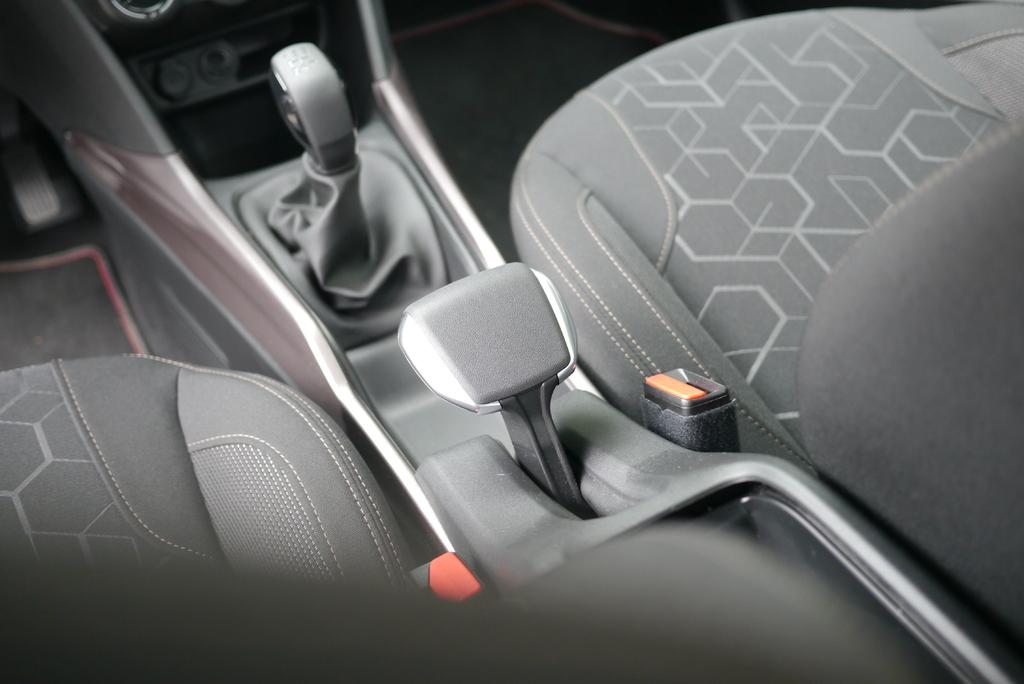What type of location is depicted in the image? The image is an inner view of a vehicle. How many seats are visible in the vehicle? There are two seats in the vehicle. What is used for changing the speed or direction of the vehicle? A gear is present in the vehicle. What else can be seen inside the vehicle besides the seats and gear? There are other objects in the vehicle. What is the color of the background in the image? The background of the image is gray in color. What type of debt is being discussed in the image? There is no mention or indication of debt in the image; it is focused on the interior of a vehicle. What scientific theory is being explored in the image? There is no scientific theory being explored in the image; it is focused on the interior of a vehicle. 